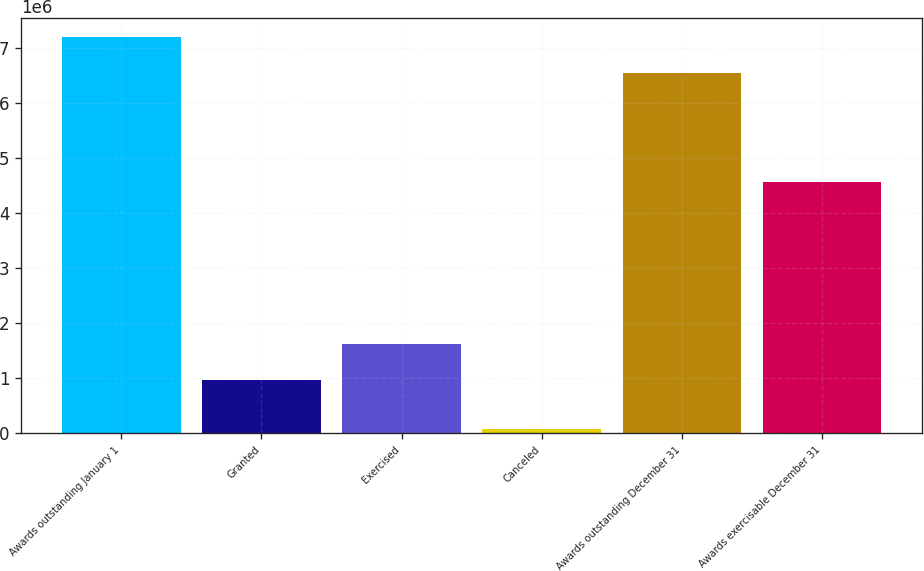Convert chart. <chart><loc_0><loc_0><loc_500><loc_500><bar_chart><fcel>Awards outstanding January 1<fcel>Granted<fcel>Exercised<fcel>Canceled<fcel>Awards outstanding December 31<fcel>Awards exercisable December 31<nl><fcel>7.19012e+06<fcel>970800<fcel>1.62577e+06<fcel>74900<fcel>6.53515e+06<fcel>4.56602e+06<nl></chart> 